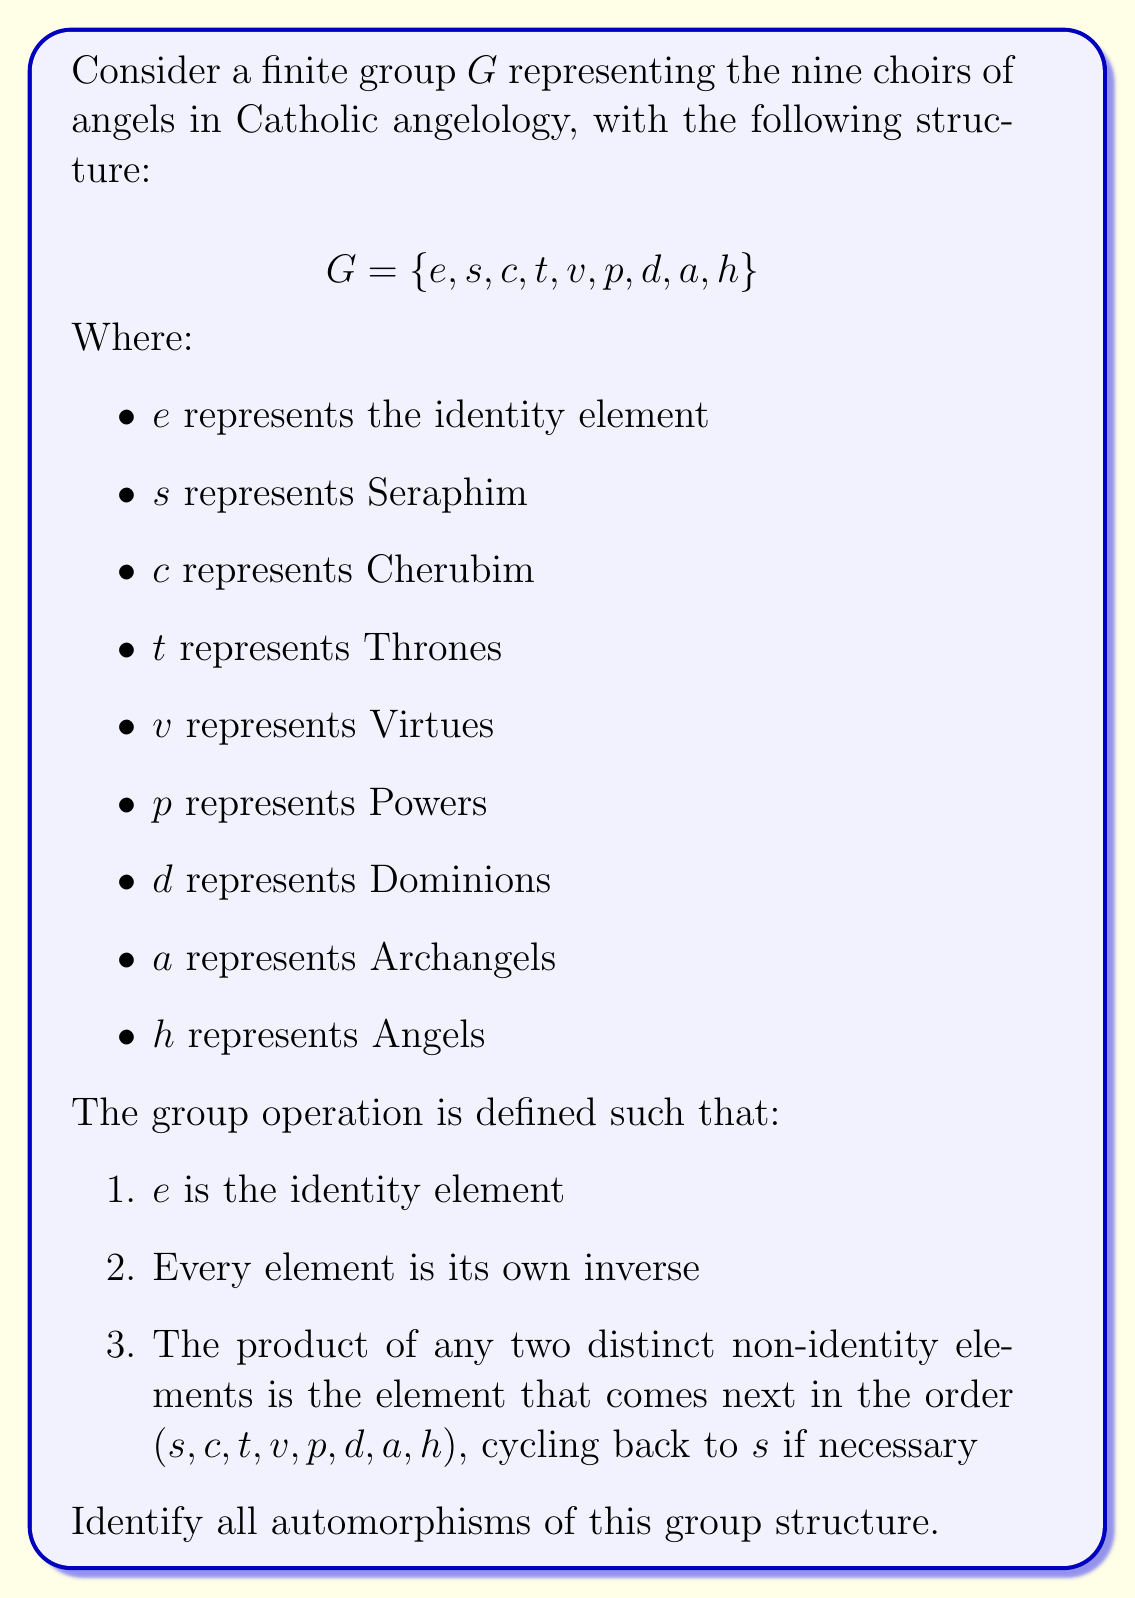Teach me how to tackle this problem. To solve this problem, let's approach it step-by-step:

1) First, recall that an automorphism is a bijective homomorphism from a group to itself. In simpler terms, it's a way of rearranging the elements of the group while preserving the group structure.

2) In this group, the identity element $e$ must always map to itself in any automorphism, as it's the only element that satisfies the identity property.

3) Now, let's consider the structure of this group. Every non-identity element has order 2 (is its own inverse), and the product of any two distinct non-identity elements follows a specific cyclic pattern.

4) Due to this structure, any automorphism must preserve the "next element" relationship. This means that if we know where $s$ maps to, we can determine where every other element maps.

5) Let's say $\phi$ is an automorphism, and $\phi(s) = x$ where $x$ is any non-identity element. Then:

   $\phi(c) = \phi(s \cdot s) = \phi(s) \cdot \phi(s) = x \cdot x = $ the element after $x$
   $\phi(t) = \phi(s \cdot c) = \phi(s) \cdot \phi(c) = x \cdot $ (the element after $x$) = the element two after $x$
   And so on...

6) This means that each automorphism is fully determined by where it sends $s$. There are 8 possibilities for where $s$ can be mapped (any non-identity element).

7) We can verify that each of these 8 mappings of $s$ indeed produces a valid automorphism, as it preserves the group structure.

Therefore, there are 8 automorphisms of this group, each corresponding to a choice of where to map $s$.
Answer: The group $G$ has 8 automorphisms, each determined by where it maps the element $s$. These automorphisms can be represented as permutations of the non-identity elements:

1) Identity: $(s)(c)(t)(v)(p)(d)(a)(h)$
2) $(s\,c\,t\,v\,p\,d\,a\,h)$
3) $(s\,t\,v\,p\,d\,a\,h\,c)$
4) $(s\,v\,p\,d\,a\,h\,c\,t)$
5) $(s\,p\,d\,a\,h\,c\,t\,v)$
6) $(s\,d\,a\,h\,c\,t\,v\,p)$
7) $(s\,a\,h\,c\,t\,v\,p\,d)$
8) $(s\,h\,c\,t\,v\,p\,d\,a)$

Each of these permutations, along with fixing the identity element $e$, defines an automorphism of the group. 